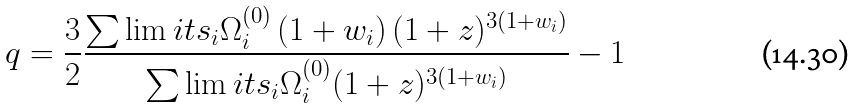<formula> <loc_0><loc_0><loc_500><loc_500>q = \frac { 3 } { 2 } \frac { { \sum \lim i t s _ { i } \Omega _ { i } ^ { ( 0 ) } \left ( { 1 + w _ { i } } \right ) ( 1 + z ) ^ { 3 \left ( { 1 + w _ { i } } \right ) } } } { { \sum \lim i t s _ { i } \Omega _ { i } ^ { ( 0 ) } ( 1 + z ) ^ { 3 \left ( { 1 + w _ { i } } \right ) } } } - 1</formula> 